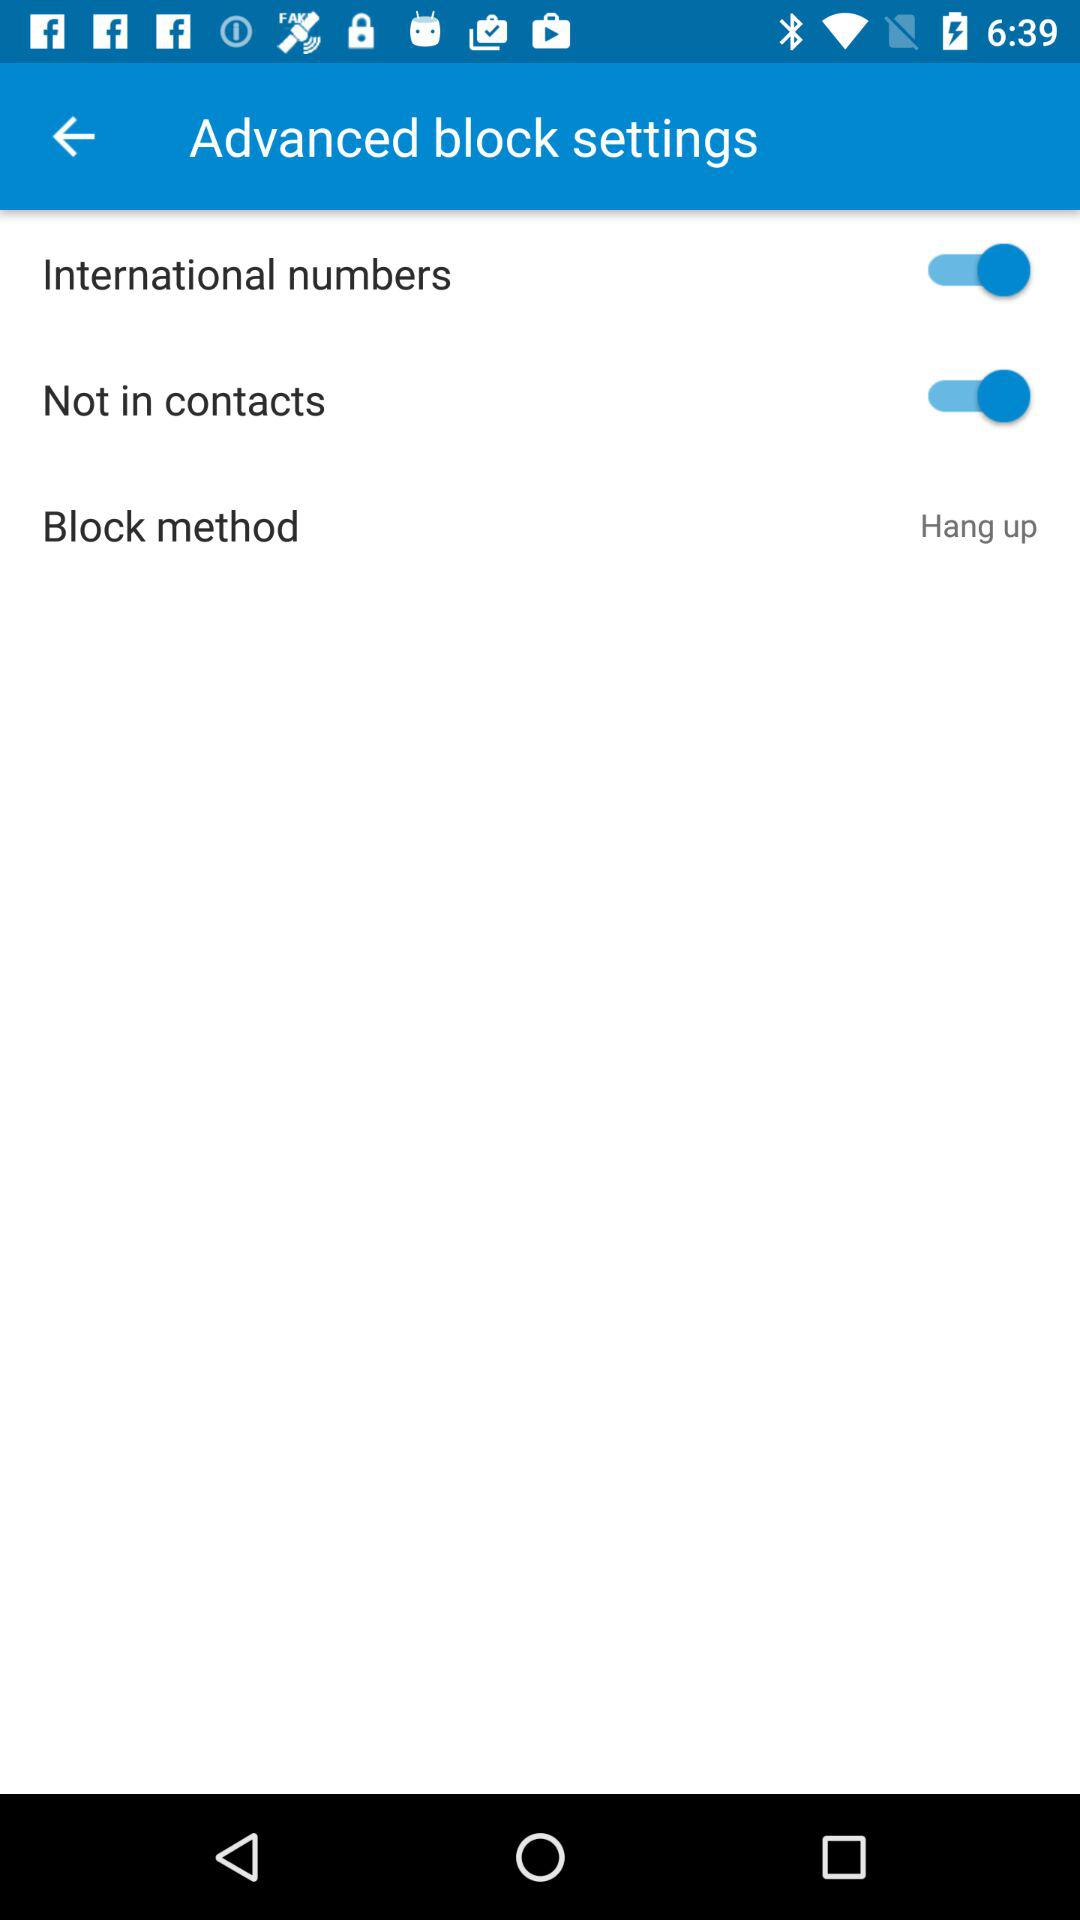How many switches are there in the advanced block settings?
Answer the question using a single word or phrase. 2 